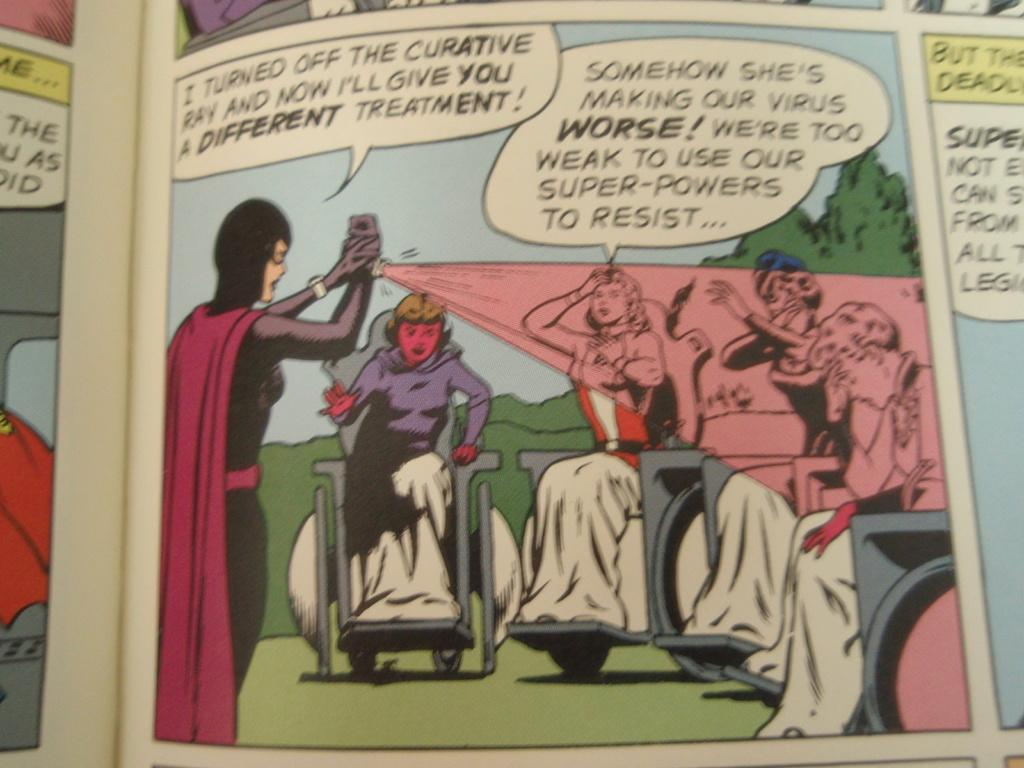<image>
Present a compact description of the photo's key features. Comic scripts about a lady making their virus weak and worse. 